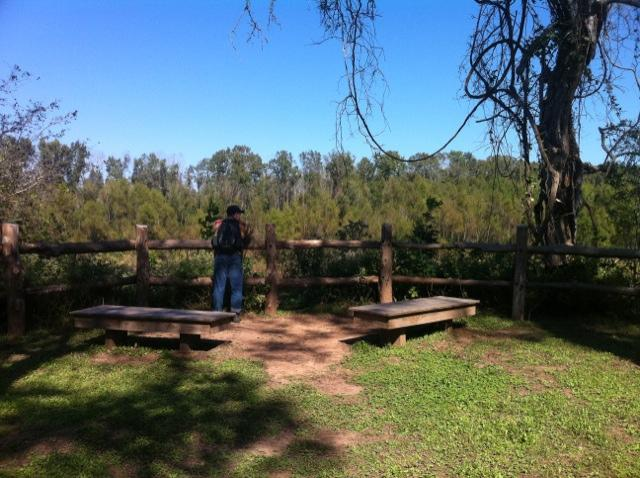What is the person leaning against? Please explain your reasoning. fence. This structure is being used to keep people from danger the man is leaning against it so that he can view without falling. 